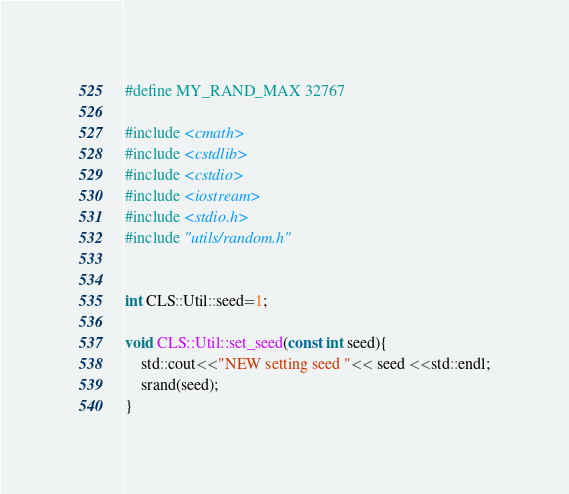<code> <loc_0><loc_0><loc_500><loc_500><_C++_>#define MY_RAND_MAX 32767

#include <cmath>
#include <cstdlib>
#include <cstdio>
#include <iostream>
#include <stdio.h>
#include "utils/random.h"


int CLS::Util::seed=1;

void CLS::Util::set_seed(const int seed){
    std::cout<<"NEW setting seed "<< seed <<std::endl;
    srand(seed);        
}

</code> 